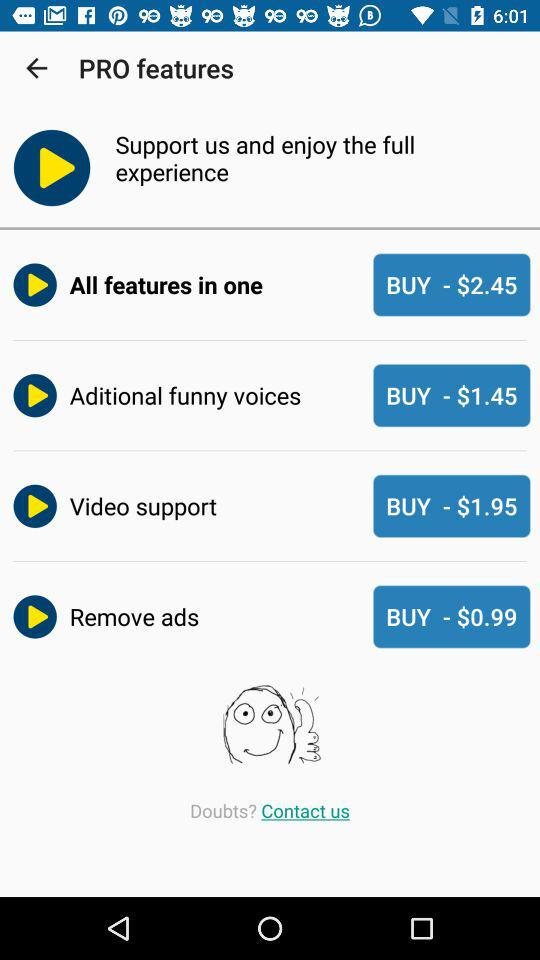What is the price of "All features in one"? The price is $2.45. 